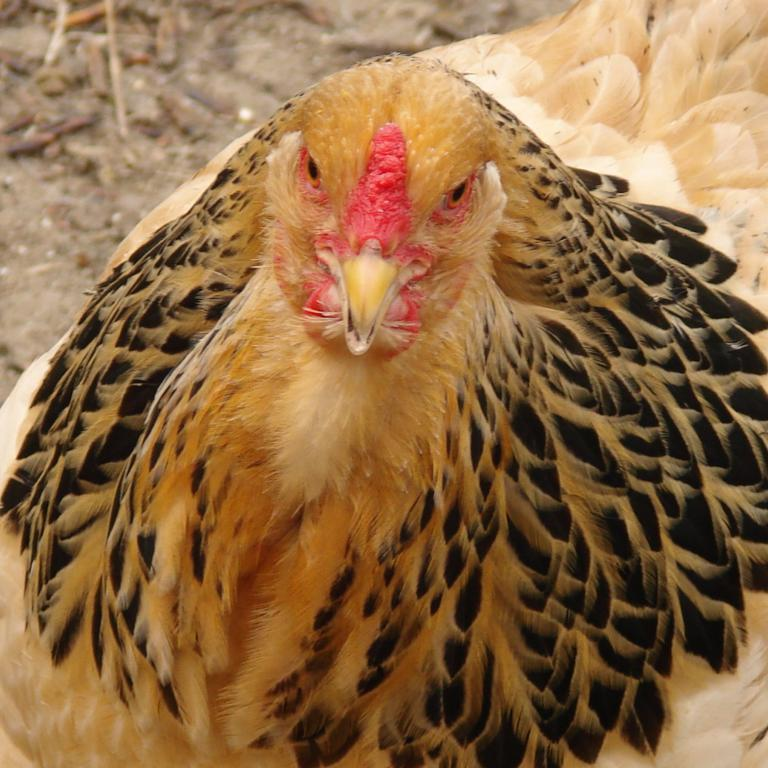What is the focus of the image? The subject of the image is a chicken. Can you describe the perspective of the image? The image is a zoomed in picture. What is the mother of the chicken doing in the image? There is no mother of the chicken present in the image. What type of rock can be seen near the chicken in the image? There is no rock visible in the image; it features a chicken in a zoomed in perspective. 